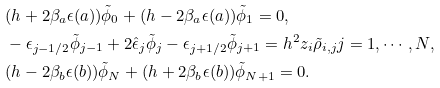Convert formula to latex. <formula><loc_0><loc_0><loc_500><loc_500>& ( h + 2 \beta _ { a } \epsilon ( a ) ) \tilde { \phi } _ { 0 } + ( h - 2 \beta _ { a } \epsilon ( a ) ) \tilde { \phi } _ { 1 } = 0 , \\ & - \epsilon _ { j - 1 / 2 } \tilde { \phi } _ { j - 1 } + 2 \hat { \epsilon } _ { j } \tilde { \phi } _ { j } - \epsilon _ { j + 1 / 2 } \tilde { \phi } _ { j + 1 } = h ^ { 2 } z _ { i } \tilde { \rho } _ { i , j } j = 1 , \cdots , N , \\ & ( h - 2 \beta _ { b } \epsilon ( b ) ) \tilde { \phi } _ { N } + ( h + 2 \beta _ { b } \epsilon ( b ) ) \tilde { \phi } _ { N + 1 } = 0 .</formula> 